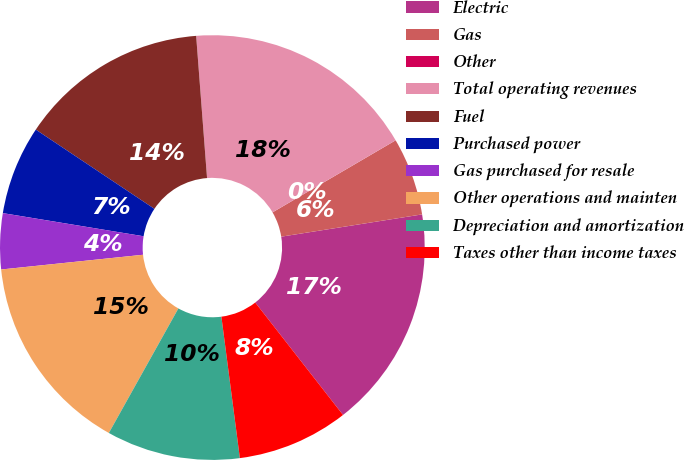Convert chart. <chart><loc_0><loc_0><loc_500><loc_500><pie_chart><fcel>Electric<fcel>Gas<fcel>Other<fcel>Total operating revenues<fcel>Fuel<fcel>Purchased power<fcel>Gas purchased for resale<fcel>Other operations and mainten<fcel>Depreciation and amortization<fcel>Taxes other than income taxes<nl><fcel>16.95%<fcel>5.93%<fcel>0.0%<fcel>17.79%<fcel>14.41%<fcel>6.78%<fcel>4.24%<fcel>15.25%<fcel>10.17%<fcel>8.48%<nl></chart> 